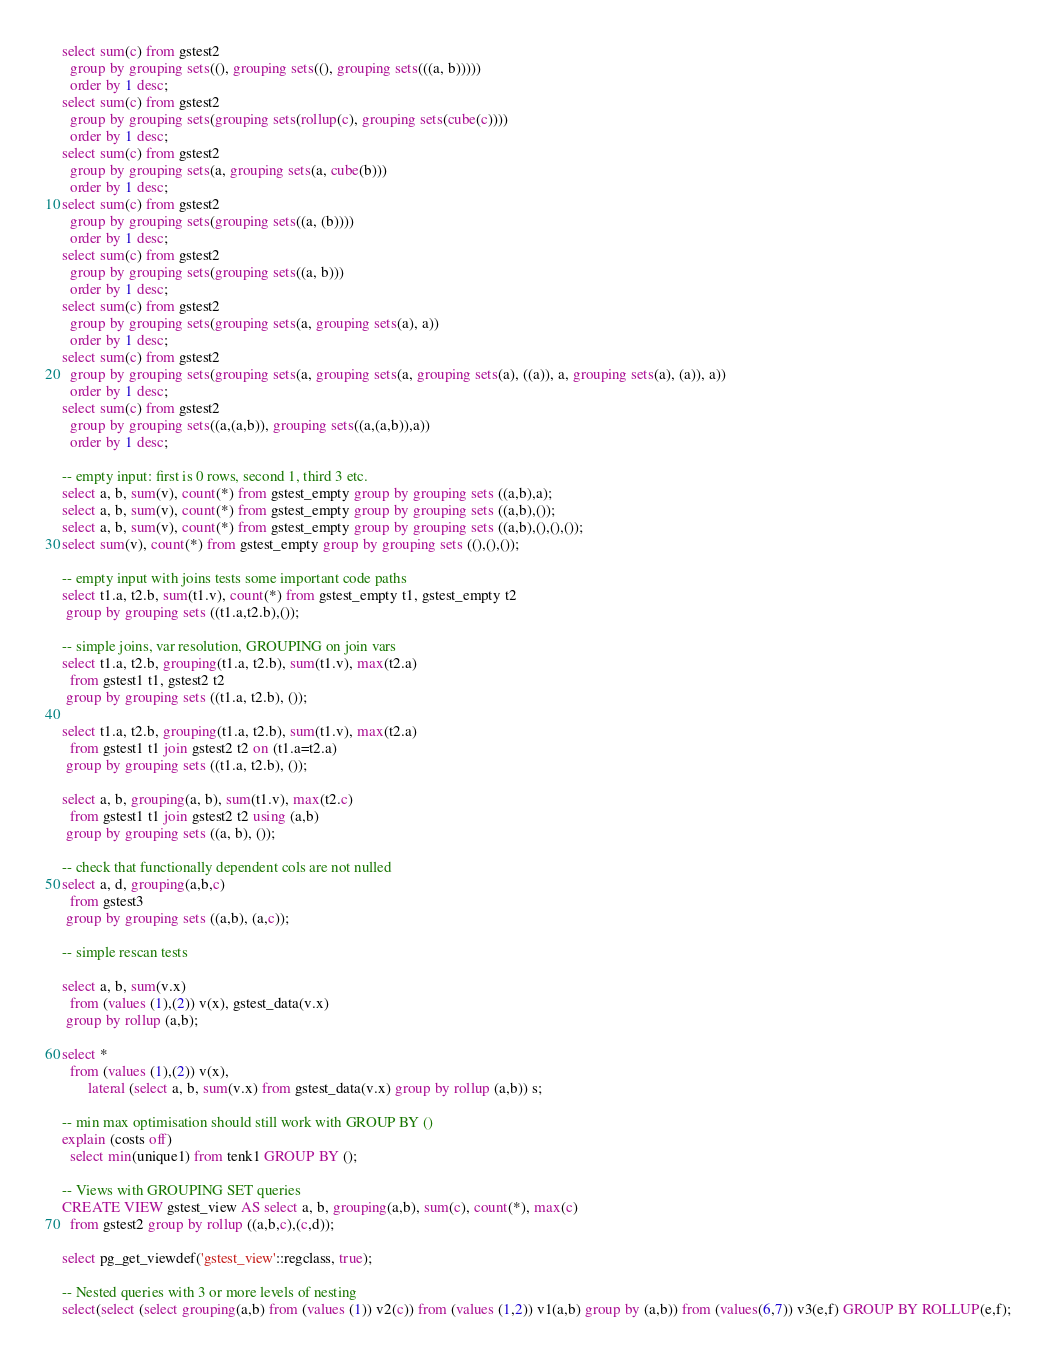Convert code to text. <code><loc_0><loc_0><loc_500><loc_500><_SQL_>select sum(c) from gstest2
  group by grouping sets((), grouping sets((), grouping sets(((a, b)))))
  order by 1 desc;
select sum(c) from gstest2
  group by grouping sets(grouping sets(rollup(c), grouping sets(cube(c))))
  order by 1 desc;
select sum(c) from gstest2
  group by grouping sets(a, grouping sets(a, cube(b)))
  order by 1 desc;
select sum(c) from gstest2
  group by grouping sets(grouping sets((a, (b))))
  order by 1 desc;
select sum(c) from gstest2
  group by grouping sets(grouping sets((a, b)))
  order by 1 desc;
select sum(c) from gstest2
  group by grouping sets(grouping sets(a, grouping sets(a), a))
  order by 1 desc;
select sum(c) from gstest2
  group by grouping sets(grouping sets(a, grouping sets(a, grouping sets(a), ((a)), a, grouping sets(a), (a)), a))
  order by 1 desc;
select sum(c) from gstest2
  group by grouping sets((a,(a,b)), grouping sets((a,(a,b)),a))
  order by 1 desc;

-- empty input: first is 0 rows, second 1, third 3 etc.
select a, b, sum(v), count(*) from gstest_empty group by grouping sets ((a,b),a);
select a, b, sum(v), count(*) from gstest_empty group by grouping sets ((a,b),());
select a, b, sum(v), count(*) from gstest_empty group by grouping sets ((a,b),(),(),());
select sum(v), count(*) from gstest_empty group by grouping sets ((),(),());

-- empty input with joins tests some important code paths
select t1.a, t2.b, sum(t1.v), count(*) from gstest_empty t1, gstest_empty t2
 group by grouping sets ((t1.a,t2.b),());

-- simple joins, var resolution, GROUPING on join vars
select t1.a, t2.b, grouping(t1.a, t2.b), sum(t1.v), max(t2.a)
  from gstest1 t1, gstest2 t2
 group by grouping sets ((t1.a, t2.b), ());

select t1.a, t2.b, grouping(t1.a, t2.b), sum(t1.v), max(t2.a)
  from gstest1 t1 join gstest2 t2 on (t1.a=t2.a)
 group by grouping sets ((t1.a, t2.b), ());

select a, b, grouping(a, b), sum(t1.v), max(t2.c)
  from gstest1 t1 join gstest2 t2 using (a,b)
 group by grouping sets ((a, b), ());

-- check that functionally dependent cols are not nulled
select a, d, grouping(a,b,c)
  from gstest3
 group by grouping sets ((a,b), (a,c));

-- simple rescan tests

select a, b, sum(v.x)
  from (values (1),(2)) v(x), gstest_data(v.x)
 group by rollup (a,b);

select *
  from (values (1),(2)) v(x),
       lateral (select a, b, sum(v.x) from gstest_data(v.x) group by rollup (a,b)) s;

-- min max optimisation should still work with GROUP BY ()
explain (costs off)
  select min(unique1) from tenk1 GROUP BY ();

-- Views with GROUPING SET queries
CREATE VIEW gstest_view AS select a, b, grouping(a,b), sum(c), count(*), max(c)
  from gstest2 group by rollup ((a,b,c),(c,d));

select pg_get_viewdef('gstest_view'::regclass, true);

-- Nested queries with 3 or more levels of nesting
select(select (select grouping(a,b) from (values (1)) v2(c)) from (values (1,2)) v1(a,b) group by (a,b)) from (values(6,7)) v3(e,f) GROUP BY ROLLUP(e,f);</code> 